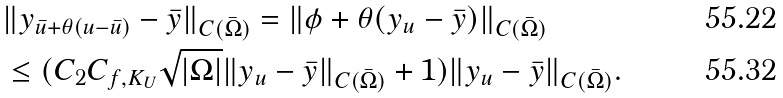Convert formula to latex. <formula><loc_0><loc_0><loc_500><loc_500>& \| y _ { \bar { u } + \theta ( u - \bar { u } ) } - \bar { y } \| _ { C ( \bar { \Omega } ) } = \| \phi + \theta ( y _ { u } - \bar { y } ) \| _ { C ( \bar { \Omega } ) } \\ & \leq ( C _ { 2 } C _ { f , K _ { U } } \sqrt { | \Omega | } \| y _ { u } - \bar { y } \| _ { C ( \bar { \Omega } ) } + 1 ) \| y _ { u } - \bar { y } \| _ { C ( \bar { \Omega } ) } .</formula> 